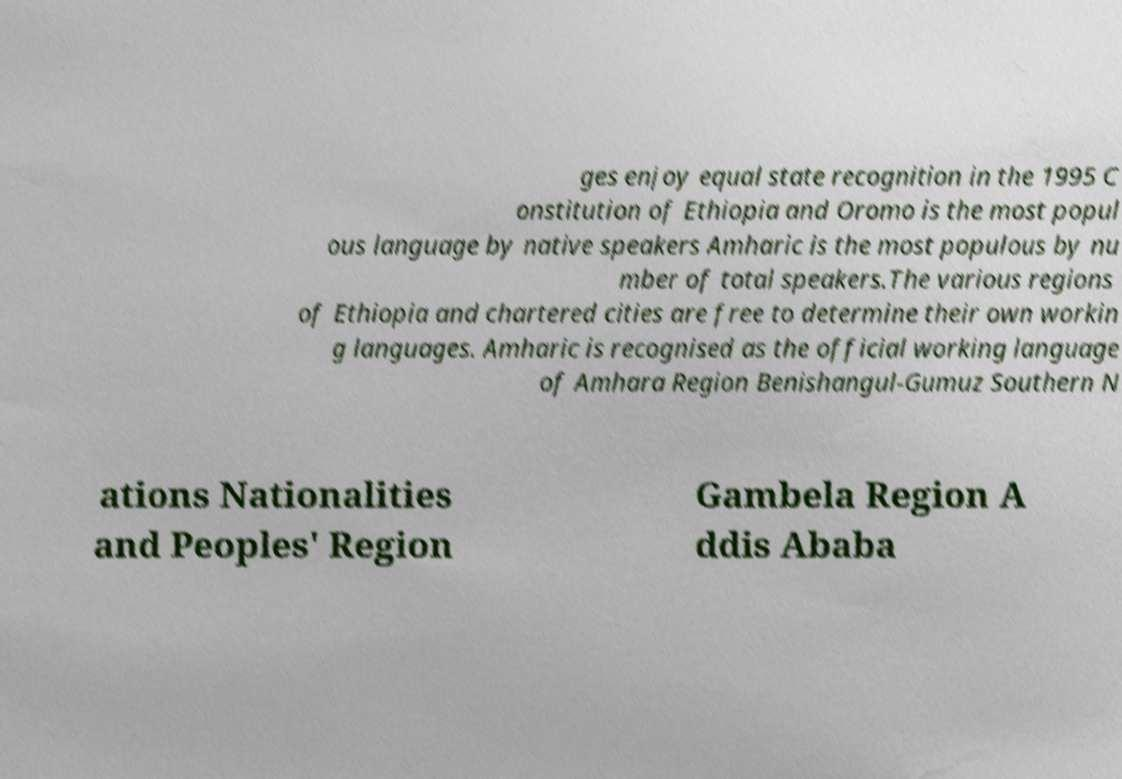Could you assist in decoding the text presented in this image and type it out clearly? ges enjoy equal state recognition in the 1995 C onstitution of Ethiopia and Oromo is the most popul ous language by native speakers Amharic is the most populous by nu mber of total speakers.The various regions of Ethiopia and chartered cities are free to determine their own workin g languages. Amharic is recognised as the official working language of Amhara Region Benishangul-Gumuz Southern N ations Nationalities and Peoples' Region Gambela Region A ddis Ababa 